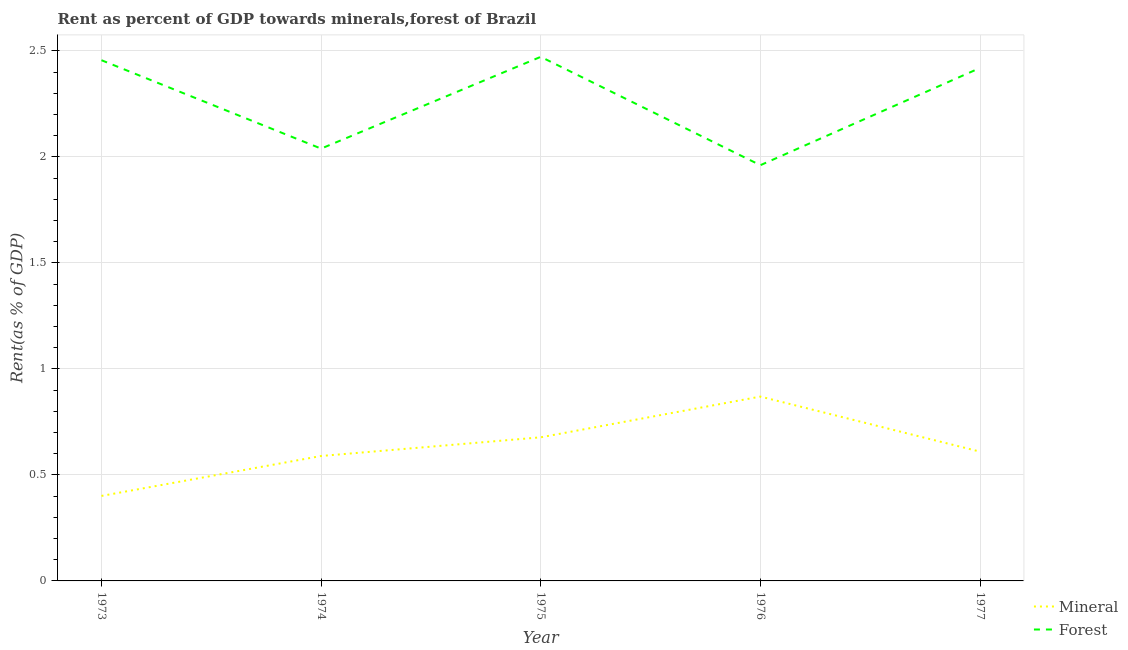Does the line corresponding to mineral rent intersect with the line corresponding to forest rent?
Your response must be concise. No. Is the number of lines equal to the number of legend labels?
Give a very brief answer. Yes. What is the forest rent in 1974?
Give a very brief answer. 2.04. Across all years, what is the maximum mineral rent?
Give a very brief answer. 0.87. Across all years, what is the minimum mineral rent?
Offer a terse response. 0.4. In which year was the forest rent maximum?
Offer a terse response. 1975. What is the total forest rent in the graph?
Provide a succinct answer. 11.35. What is the difference between the forest rent in 1973 and that in 1974?
Your answer should be very brief. 0.42. What is the difference between the forest rent in 1977 and the mineral rent in 1973?
Your response must be concise. 2.02. What is the average forest rent per year?
Ensure brevity in your answer.  2.27. In the year 1974, what is the difference between the mineral rent and forest rent?
Provide a short and direct response. -1.45. What is the ratio of the forest rent in 1973 to that in 1977?
Ensure brevity in your answer.  1.02. Is the mineral rent in 1974 less than that in 1976?
Keep it short and to the point. Yes. Is the difference between the mineral rent in 1973 and 1975 greater than the difference between the forest rent in 1973 and 1975?
Provide a succinct answer. No. What is the difference between the highest and the second highest mineral rent?
Ensure brevity in your answer.  0.19. What is the difference between the highest and the lowest forest rent?
Give a very brief answer. 0.51. In how many years, is the forest rent greater than the average forest rent taken over all years?
Make the answer very short. 3. Does the forest rent monotonically increase over the years?
Your answer should be compact. No. Is the mineral rent strictly greater than the forest rent over the years?
Offer a very short reply. No. Is the forest rent strictly less than the mineral rent over the years?
Offer a terse response. No. How many years are there in the graph?
Ensure brevity in your answer.  5. How many legend labels are there?
Give a very brief answer. 2. How are the legend labels stacked?
Your answer should be compact. Vertical. What is the title of the graph?
Provide a succinct answer. Rent as percent of GDP towards minerals,forest of Brazil. Does "Central government" appear as one of the legend labels in the graph?
Make the answer very short. No. What is the label or title of the X-axis?
Keep it short and to the point. Year. What is the label or title of the Y-axis?
Make the answer very short. Rent(as % of GDP). What is the Rent(as % of GDP) of Mineral in 1973?
Provide a succinct answer. 0.4. What is the Rent(as % of GDP) in Forest in 1973?
Your answer should be very brief. 2.46. What is the Rent(as % of GDP) of Mineral in 1974?
Make the answer very short. 0.59. What is the Rent(as % of GDP) in Forest in 1974?
Your answer should be very brief. 2.04. What is the Rent(as % of GDP) of Mineral in 1975?
Provide a short and direct response. 0.68. What is the Rent(as % of GDP) of Forest in 1975?
Keep it short and to the point. 2.47. What is the Rent(as % of GDP) of Mineral in 1976?
Make the answer very short. 0.87. What is the Rent(as % of GDP) in Forest in 1976?
Your answer should be compact. 1.96. What is the Rent(as % of GDP) in Mineral in 1977?
Provide a succinct answer. 0.61. What is the Rent(as % of GDP) of Forest in 1977?
Keep it short and to the point. 2.42. Across all years, what is the maximum Rent(as % of GDP) in Mineral?
Your answer should be compact. 0.87. Across all years, what is the maximum Rent(as % of GDP) in Forest?
Give a very brief answer. 2.47. Across all years, what is the minimum Rent(as % of GDP) of Mineral?
Offer a terse response. 0.4. Across all years, what is the minimum Rent(as % of GDP) in Forest?
Your answer should be very brief. 1.96. What is the total Rent(as % of GDP) of Mineral in the graph?
Your response must be concise. 3.15. What is the total Rent(as % of GDP) in Forest in the graph?
Keep it short and to the point. 11.35. What is the difference between the Rent(as % of GDP) of Mineral in 1973 and that in 1974?
Ensure brevity in your answer.  -0.19. What is the difference between the Rent(as % of GDP) in Forest in 1973 and that in 1974?
Your response must be concise. 0.42. What is the difference between the Rent(as % of GDP) of Mineral in 1973 and that in 1975?
Keep it short and to the point. -0.28. What is the difference between the Rent(as % of GDP) in Forest in 1973 and that in 1975?
Provide a short and direct response. -0.02. What is the difference between the Rent(as % of GDP) in Mineral in 1973 and that in 1976?
Keep it short and to the point. -0.47. What is the difference between the Rent(as % of GDP) of Forest in 1973 and that in 1976?
Offer a very short reply. 0.5. What is the difference between the Rent(as % of GDP) of Mineral in 1973 and that in 1977?
Offer a very short reply. -0.21. What is the difference between the Rent(as % of GDP) in Forest in 1973 and that in 1977?
Your answer should be very brief. 0.04. What is the difference between the Rent(as % of GDP) of Mineral in 1974 and that in 1975?
Give a very brief answer. -0.09. What is the difference between the Rent(as % of GDP) in Forest in 1974 and that in 1975?
Your response must be concise. -0.43. What is the difference between the Rent(as % of GDP) of Mineral in 1974 and that in 1976?
Keep it short and to the point. -0.28. What is the difference between the Rent(as % of GDP) in Forest in 1974 and that in 1976?
Provide a succinct answer. 0.08. What is the difference between the Rent(as % of GDP) in Mineral in 1974 and that in 1977?
Offer a terse response. -0.02. What is the difference between the Rent(as % of GDP) of Forest in 1974 and that in 1977?
Your answer should be very brief. -0.38. What is the difference between the Rent(as % of GDP) in Mineral in 1975 and that in 1976?
Provide a succinct answer. -0.19. What is the difference between the Rent(as % of GDP) in Forest in 1975 and that in 1976?
Keep it short and to the point. 0.51. What is the difference between the Rent(as % of GDP) of Mineral in 1975 and that in 1977?
Your response must be concise. 0.07. What is the difference between the Rent(as % of GDP) of Forest in 1975 and that in 1977?
Offer a very short reply. 0.05. What is the difference between the Rent(as % of GDP) in Mineral in 1976 and that in 1977?
Ensure brevity in your answer.  0.26. What is the difference between the Rent(as % of GDP) in Forest in 1976 and that in 1977?
Your response must be concise. -0.46. What is the difference between the Rent(as % of GDP) of Mineral in 1973 and the Rent(as % of GDP) of Forest in 1974?
Ensure brevity in your answer.  -1.64. What is the difference between the Rent(as % of GDP) in Mineral in 1973 and the Rent(as % of GDP) in Forest in 1975?
Your response must be concise. -2.07. What is the difference between the Rent(as % of GDP) in Mineral in 1973 and the Rent(as % of GDP) in Forest in 1976?
Provide a succinct answer. -1.56. What is the difference between the Rent(as % of GDP) in Mineral in 1973 and the Rent(as % of GDP) in Forest in 1977?
Offer a very short reply. -2.02. What is the difference between the Rent(as % of GDP) of Mineral in 1974 and the Rent(as % of GDP) of Forest in 1975?
Keep it short and to the point. -1.88. What is the difference between the Rent(as % of GDP) of Mineral in 1974 and the Rent(as % of GDP) of Forest in 1976?
Your response must be concise. -1.37. What is the difference between the Rent(as % of GDP) of Mineral in 1974 and the Rent(as % of GDP) of Forest in 1977?
Keep it short and to the point. -1.83. What is the difference between the Rent(as % of GDP) of Mineral in 1975 and the Rent(as % of GDP) of Forest in 1976?
Make the answer very short. -1.28. What is the difference between the Rent(as % of GDP) in Mineral in 1975 and the Rent(as % of GDP) in Forest in 1977?
Give a very brief answer. -1.74. What is the difference between the Rent(as % of GDP) in Mineral in 1976 and the Rent(as % of GDP) in Forest in 1977?
Make the answer very short. -1.55. What is the average Rent(as % of GDP) of Mineral per year?
Keep it short and to the point. 0.63. What is the average Rent(as % of GDP) of Forest per year?
Provide a succinct answer. 2.27. In the year 1973, what is the difference between the Rent(as % of GDP) in Mineral and Rent(as % of GDP) in Forest?
Give a very brief answer. -2.06. In the year 1974, what is the difference between the Rent(as % of GDP) of Mineral and Rent(as % of GDP) of Forest?
Make the answer very short. -1.45. In the year 1975, what is the difference between the Rent(as % of GDP) of Mineral and Rent(as % of GDP) of Forest?
Ensure brevity in your answer.  -1.79. In the year 1976, what is the difference between the Rent(as % of GDP) in Mineral and Rent(as % of GDP) in Forest?
Your response must be concise. -1.09. In the year 1977, what is the difference between the Rent(as % of GDP) of Mineral and Rent(as % of GDP) of Forest?
Provide a succinct answer. -1.81. What is the ratio of the Rent(as % of GDP) of Mineral in 1973 to that in 1974?
Provide a succinct answer. 0.68. What is the ratio of the Rent(as % of GDP) in Forest in 1973 to that in 1974?
Keep it short and to the point. 1.2. What is the ratio of the Rent(as % of GDP) in Mineral in 1973 to that in 1975?
Your response must be concise. 0.59. What is the ratio of the Rent(as % of GDP) in Forest in 1973 to that in 1975?
Keep it short and to the point. 0.99. What is the ratio of the Rent(as % of GDP) in Mineral in 1973 to that in 1976?
Your answer should be compact. 0.46. What is the ratio of the Rent(as % of GDP) in Forest in 1973 to that in 1976?
Make the answer very short. 1.25. What is the ratio of the Rent(as % of GDP) of Mineral in 1973 to that in 1977?
Keep it short and to the point. 0.66. What is the ratio of the Rent(as % of GDP) in Forest in 1973 to that in 1977?
Make the answer very short. 1.02. What is the ratio of the Rent(as % of GDP) in Mineral in 1974 to that in 1975?
Ensure brevity in your answer.  0.87. What is the ratio of the Rent(as % of GDP) of Forest in 1974 to that in 1975?
Your response must be concise. 0.82. What is the ratio of the Rent(as % of GDP) in Mineral in 1974 to that in 1976?
Keep it short and to the point. 0.68. What is the ratio of the Rent(as % of GDP) of Forest in 1974 to that in 1976?
Your answer should be compact. 1.04. What is the ratio of the Rent(as % of GDP) in Mineral in 1974 to that in 1977?
Offer a very short reply. 0.97. What is the ratio of the Rent(as % of GDP) of Forest in 1974 to that in 1977?
Your answer should be compact. 0.84. What is the ratio of the Rent(as % of GDP) in Mineral in 1975 to that in 1976?
Provide a short and direct response. 0.78. What is the ratio of the Rent(as % of GDP) in Forest in 1975 to that in 1976?
Make the answer very short. 1.26. What is the ratio of the Rent(as % of GDP) of Mineral in 1975 to that in 1977?
Your answer should be very brief. 1.11. What is the ratio of the Rent(as % of GDP) in Forest in 1975 to that in 1977?
Keep it short and to the point. 1.02. What is the ratio of the Rent(as % of GDP) of Mineral in 1976 to that in 1977?
Offer a very short reply. 1.43. What is the ratio of the Rent(as % of GDP) in Forest in 1976 to that in 1977?
Your answer should be compact. 0.81. What is the difference between the highest and the second highest Rent(as % of GDP) in Mineral?
Provide a short and direct response. 0.19. What is the difference between the highest and the second highest Rent(as % of GDP) in Forest?
Keep it short and to the point. 0.02. What is the difference between the highest and the lowest Rent(as % of GDP) in Mineral?
Offer a terse response. 0.47. What is the difference between the highest and the lowest Rent(as % of GDP) in Forest?
Ensure brevity in your answer.  0.51. 